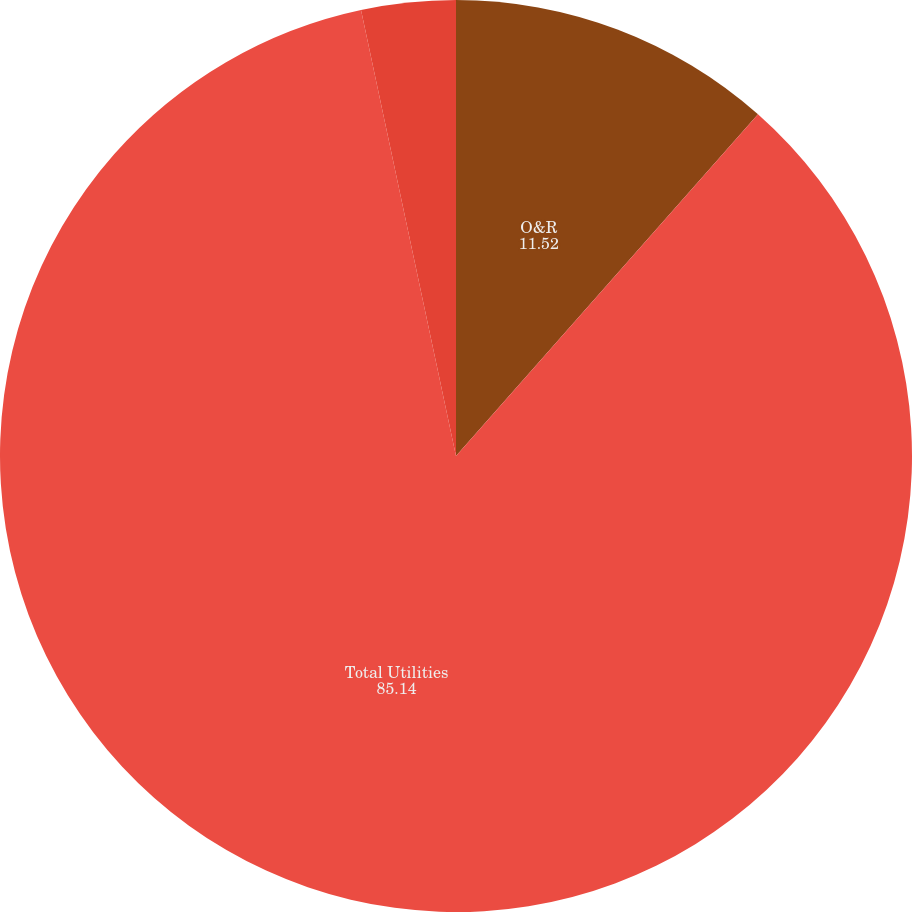<chart> <loc_0><loc_0><loc_500><loc_500><pie_chart><fcel>O&R<fcel>Total Utilities<fcel>Con Edison Solutions(a)<nl><fcel>11.52%<fcel>85.14%<fcel>3.34%<nl></chart> 